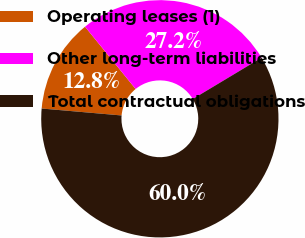<chart> <loc_0><loc_0><loc_500><loc_500><pie_chart><fcel>Operating leases (1)<fcel>Other long-term liabilities<fcel>Total contractual obligations<nl><fcel>12.76%<fcel>27.25%<fcel>59.99%<nl></chart> 